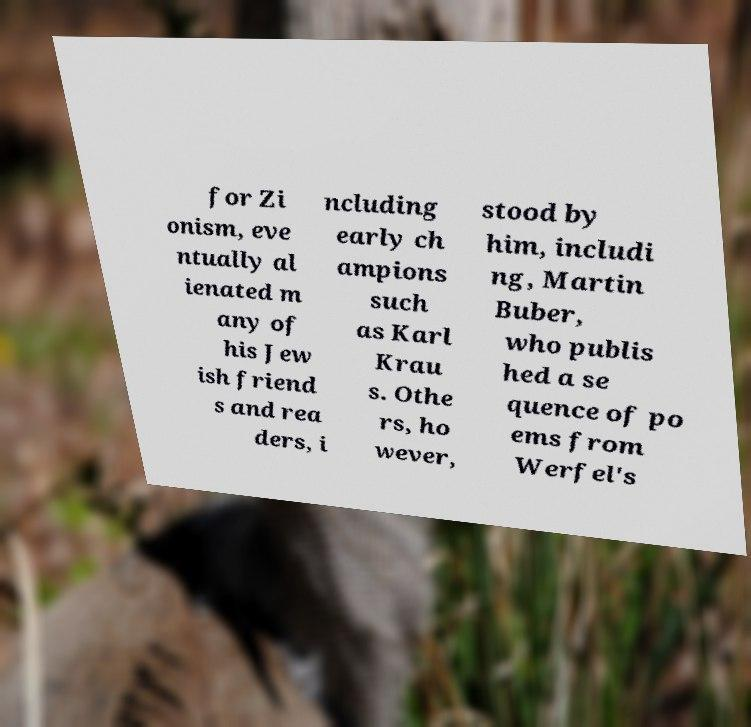Could you assist in decoding the text presented in this image and type it out clearly? for Zi onism, eve ntually al ienated m any of his Jew ish friend s and rea ders, i ncluding early ch ampions such as Karl Krau s. Othe rs, ho wever, stood by him, includi ng, Martin Buber, who publis hed a se quence of po ems from Werfel's 